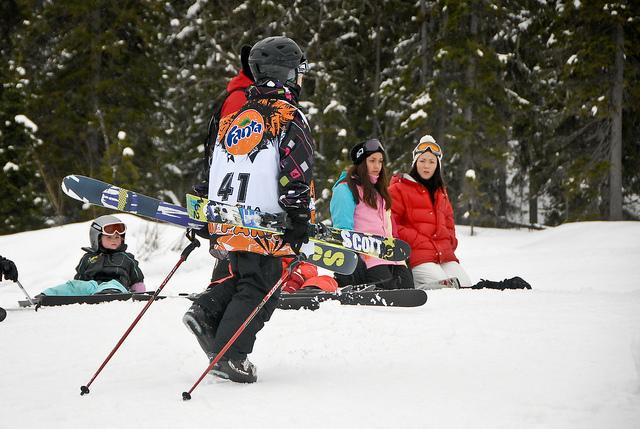What color are the poles dragged around by the young child with his skis? red 